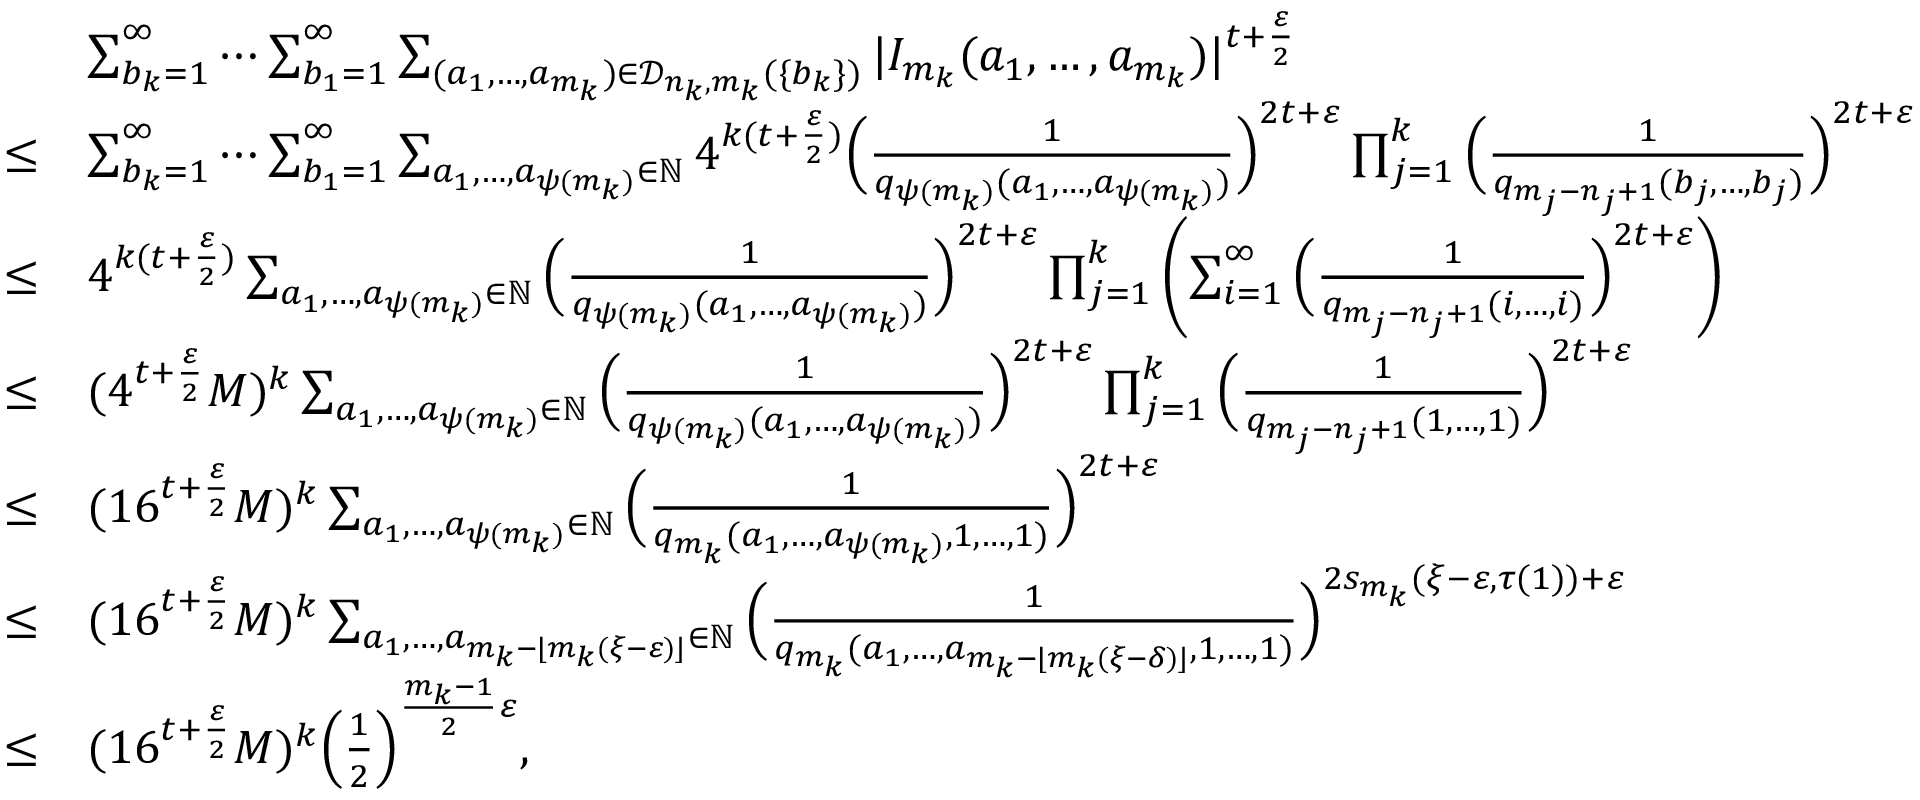Convert formula to latex. <formula><loc_0><loc_0><loc_500><loc_500>\begin{array} { r l } & { \sum _ { b _ { k } = 1 } ^ { \infty } \cdots \sum _ { b _ { 1 } = 1 } ^ { \infty } \sum _ { ( a _ { 1 } , \dots , a _ { m _ { k } } ) \in \mathcal { D } _ { n _ { k } , m _ { k } } ( \{ b _ { k } \} ) } | I _ { m _ { k } } ( a _ { 1 } , \dots , a _ { m _ { k } } ) | ^ { t + \frac { \varepsilon } { 2 } } } \\ { \leq } & { \sum _ { b _ { k } = 1 } ^ { \infty } \cdots \sum _ { b _ { 1 } = 1 } ^ { \infty } \sum _ { a _ { 1 } , \dots , a _ { \psi ( m _ { k } ) } \in \mathbb { N } } 4 ^ { k ( t + \frac { \varepsilon } { 2 } ) } \left ( \frac { 1 } { q _ { \psi ( m _ { k } ) } ( a _ { 1 } , \dots , a _ { \psi ( m _ { k } ) } ) } \right ) ^ { 2 t + \varepsilon } \prod _ { j = 1 } ^ { k } \left ( \frac { 1 } { q _ { m _ { j } - n _ { j } + 1 } ( b _ { j } , \dots , b _ { j } ) } \right ) ^ { 2 t + \varepsilon } } \\ { \leq } & { 4 ^ { k ( t + \frac { \varepsilon } { 2 } ) } \sum _ { a _ { 1 } , \dots , a _ { \psi ( m _ { k } ) } \in \mathbb { N } } \left ( \frac { 1 } { q _ { \psi ( m _ { k } ) } ( a _ { 1 } , \dots , a _ { \psi ( m _ { k } ) } ) } \right ) ^ { 2 t + \varepsilon } \prod _ { j = 1 } ^ { k } \left ( \sum _ { i = 1 } ^ { \infty } \left ( \frac { 1 } { q _ { m _ { j } - n _ { j } + 1 } ( i , \dots , i ) } \right ) ^ { 2 t + \varepsilon } \right ) } \\ { \leq } & { ( 4 ^ { t + \frac { \varepsilon } { 2 } } M ) ^ { k } \sum _ { a _ { 1 } , \dots , a _ { \psi ( m _ { k } ) } \in \mathbb { N } } \left ( \frac { 1 } { q _ { \psi ( m _ { k } ) } ( a _ { 1 } , \dots , a _ { \psi ( m _ { k } ) } ) } \right ) ^ { 2 t + \varepsilon } \prod _ { j = 1 } ^ { k } \left ( \frac { 1 } { q _ { m _ { j } - n _ { j } + 1 } ( 1 , \dots , 1 ) } \right ) ^ { 2 t + \varepsilon } } \\ { \leq } & { ( 1 6 ^ { t + \frac { \varepsilon } { 2 } } M ) ^ { k } \sum _ { a _ { 1 } , \dots , a _ { \psi ( m _ { k } ) } \in \mathbb { N } } \left ( \frac { 1 } { q _ { m _ { k } } ( a _ { 1 } , \dots , a _ { \psi ( m _ { k } ) } , 1 , \dots , 1 ) } \right ) ^ { 2 t + \varepsilon } } \\ { \leq } & { ( 1 6 ^ { t + \frac { \varepsilon } { 2 } } M ) ^ { k } \sum _ { a _ { 1 } , \dots , a _ { m _ { k } - \lfloor m _ { k } ( \xi - \varepsilon ) \rfloor } \in \mathbb { N } } \left ( \frac { 1 } { q _ { m _ { k } } ( a _ { 1 } , \dots , a _ { m _ { k } - \lfloor m _ { k } ( \xi - \delta ) \rfloor } , 1 , \dots , 1 ) } \right ) ^ { 2 s _ { m _ { k } } ( \xi - \varepsilon , { \tau ( 1 ) } ) + \varepsilon } } \\ { \leq } & { ( 1 6 ^ { t + \frac { \varepsilon } { 2 } } M ) ^ { k } \left ( \frac { 1 } { 2 } \right ) ^ { \frac { m _ { k } - 1 } { 2 } \varepsilon } , } \end{array}</formula> 